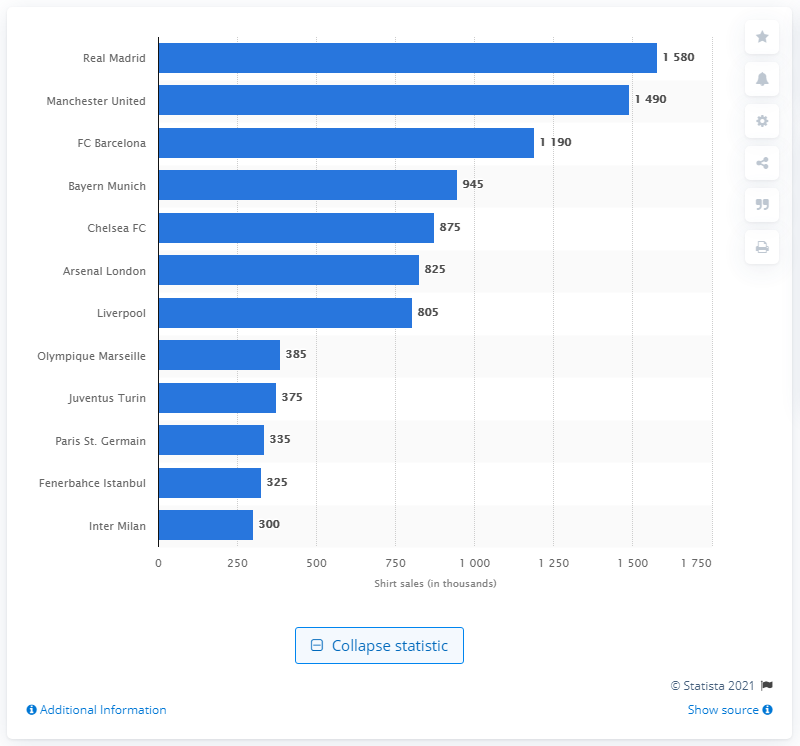Point out several critical features in this image. According to recent data, Real Madrid sells approximately 1490 replica shirts annually. 